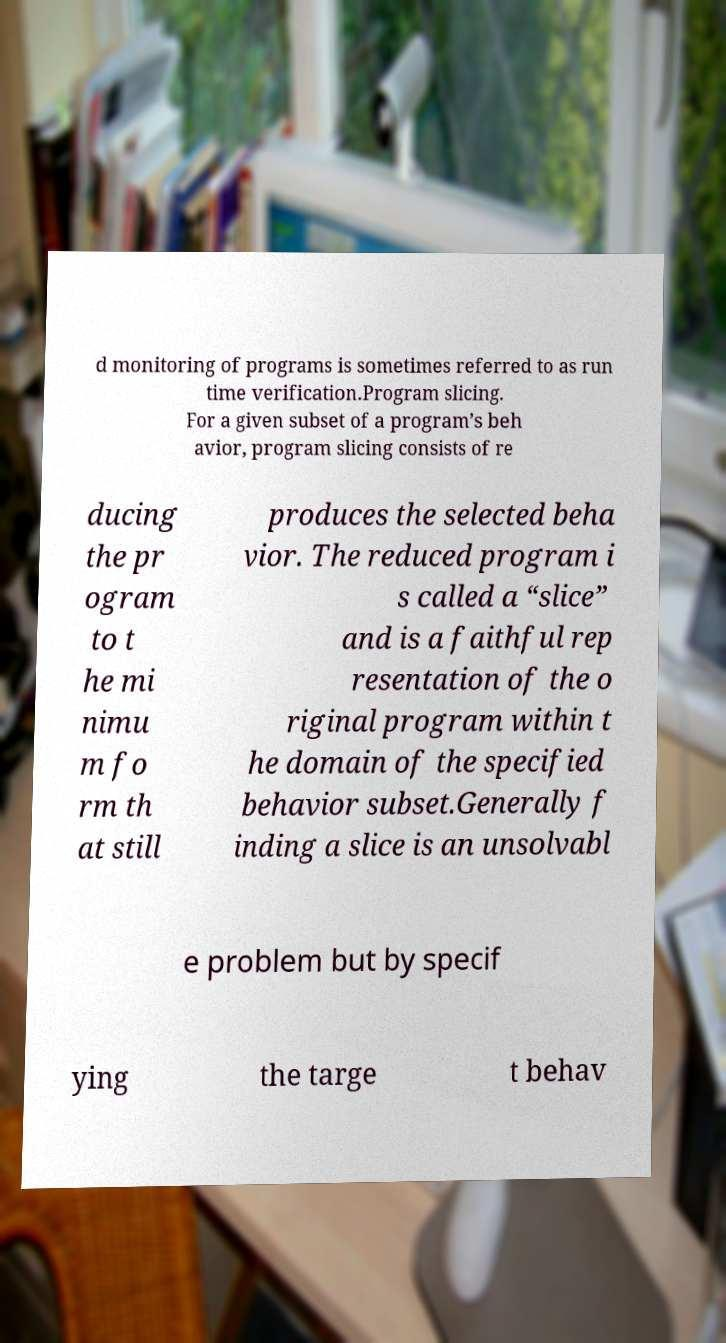What messages or text are displayed in this image? I need them in a readable, typed format. d monitoring of programs is sometimes referred to as run time verification.Program slicing. For a given subset of a program’s beh avior, program slicing consists of re ducing the pr ogram to t he mi nimu m fo rm th at still produces the selected beha vior. The reduced program i s called a “slice” and is a faithful rep resentation of the o riginal program within t he domain of the specified behavior subset.Generally f inding a slice is an unsolvabl e problem but by specif ying the targe t behav 